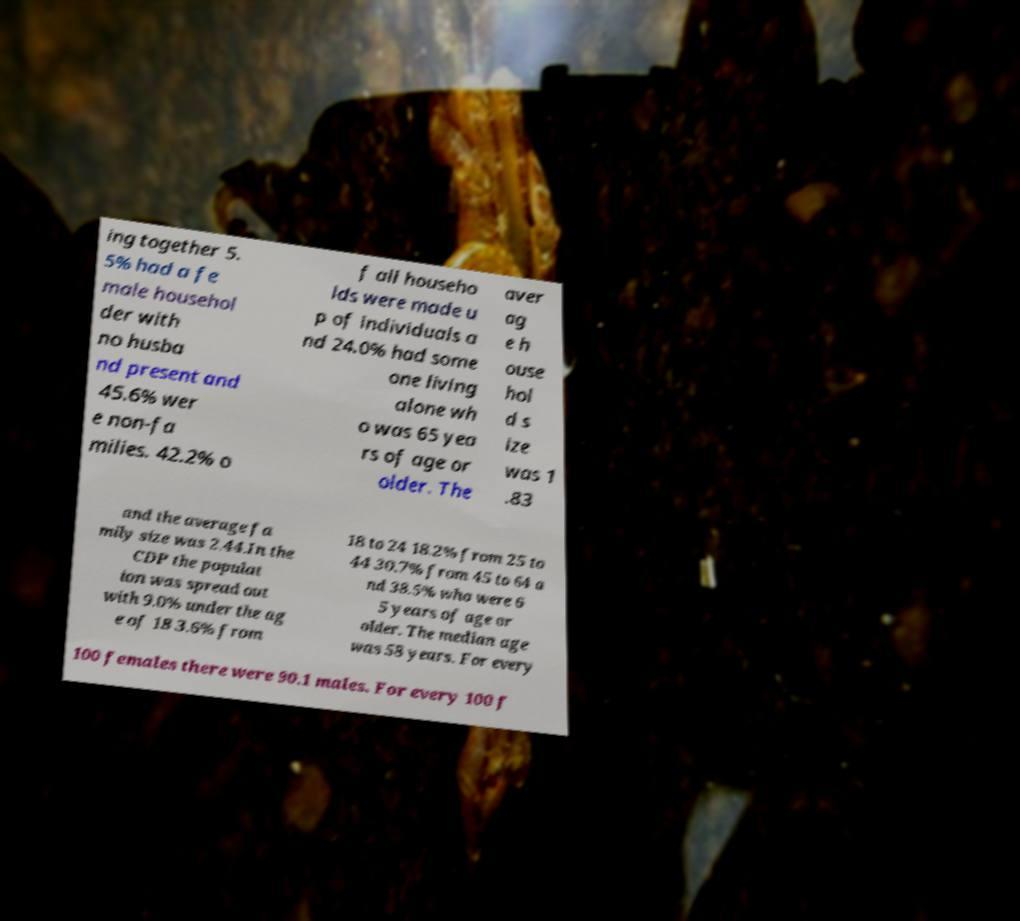Could you extract and type out the text from this image? ing together 5. 5% had a fe male househol der with no husba nd present and 45.6% wer e non-fa milies. 42.2% o f all househo lds were made u p of individuals a nd 24.0% had some one living alone wh o was 65 yea rs of age or older. The aver ag e h ouse hol d s ize was 1 .83 and the average fa mily size was 2.44.In the CDP the populat ion was spread out with 9.0% under the ag e of 18 3.6% from 18 to 24 18.2% from 25 to 44 30.7% from 45 to 64 a nd 38.5% who were 6 5 years of age or older. The median age was 58 years. For every 100 females there were 90.1 males. For every 100 f 